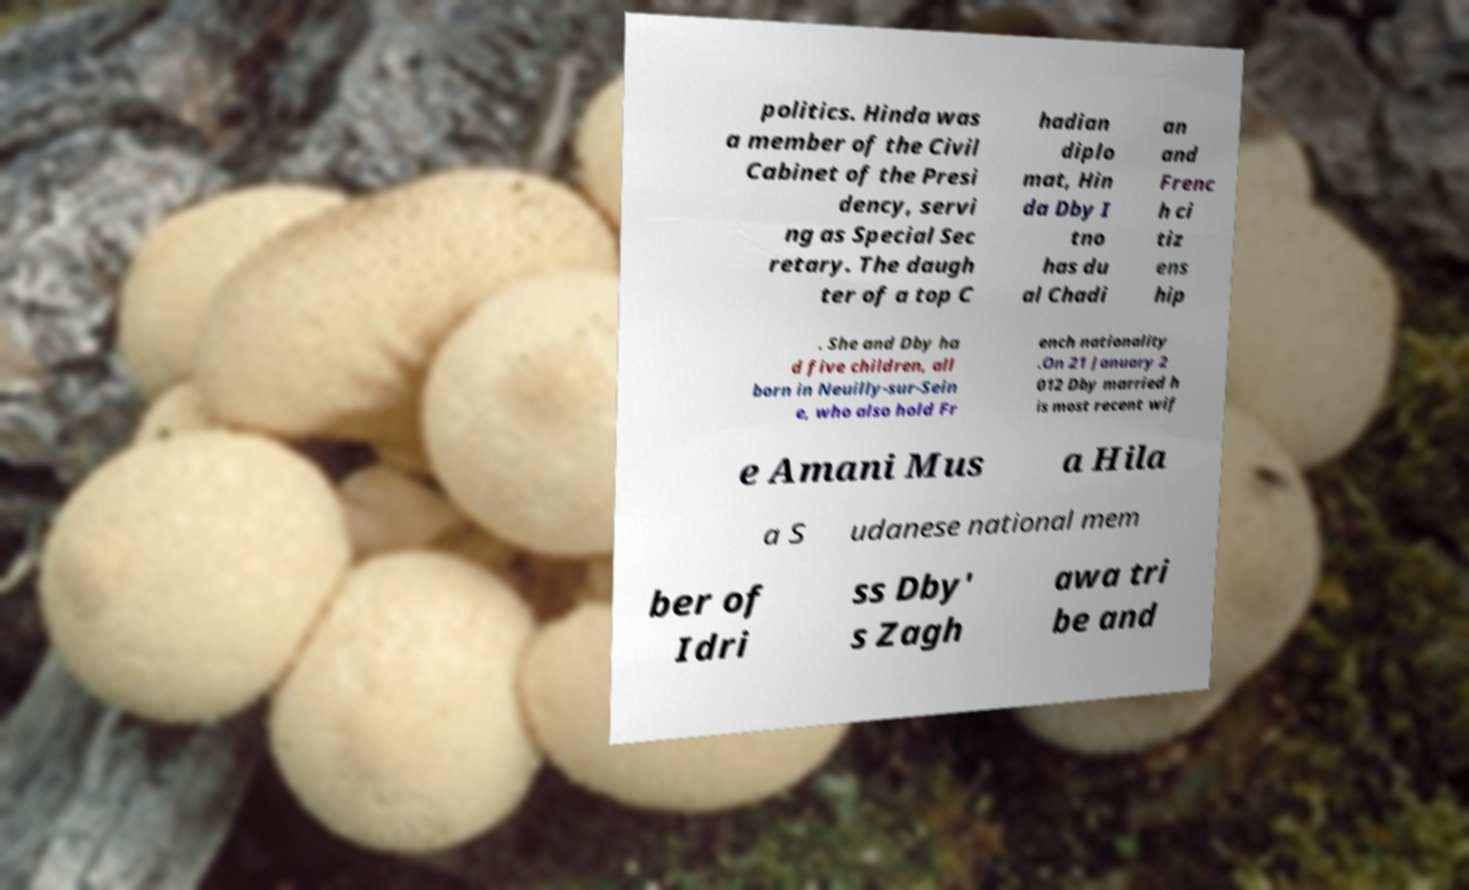Could you extract and type out the text from this image? politics. Hinda was a member of the Civil Cabinet of the Presi dency, servi ng as Special Sec retary. The daugh ter of a top C hadian diplo mat, Hin da Dby I tno has du al Chadi an and Frenc h ci tiz ens hip . She and Dby ha d five children, all born in Neuilly-sur-Sein e, who also hold Fr ench nationality .On 21 January 2 012 Dby married h is most recent wif e Amani Mus a Hila a S udanese national mem ber of Idri ss Dby' s Zagh awa tri be and 